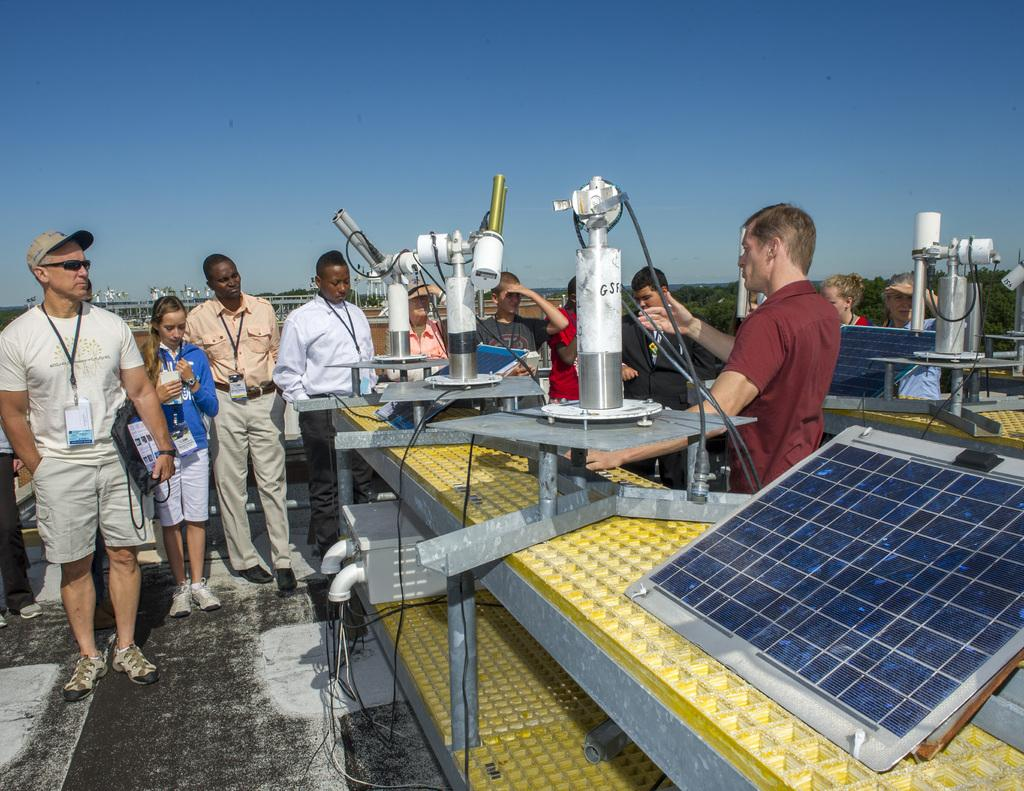How many people are present in the image? There are many people standing in the image. What else can be seen in the image besides the people? There are machines and a solar panel in the image. What is visible in the background of the image? There are trees in the background of the image. What is the condition of the sky in the image? The sky is clear in the image. What type of wheel can be seen in the image? There is no wheel present in the image. Is there a club visible in the image? There is no club present in the image. 